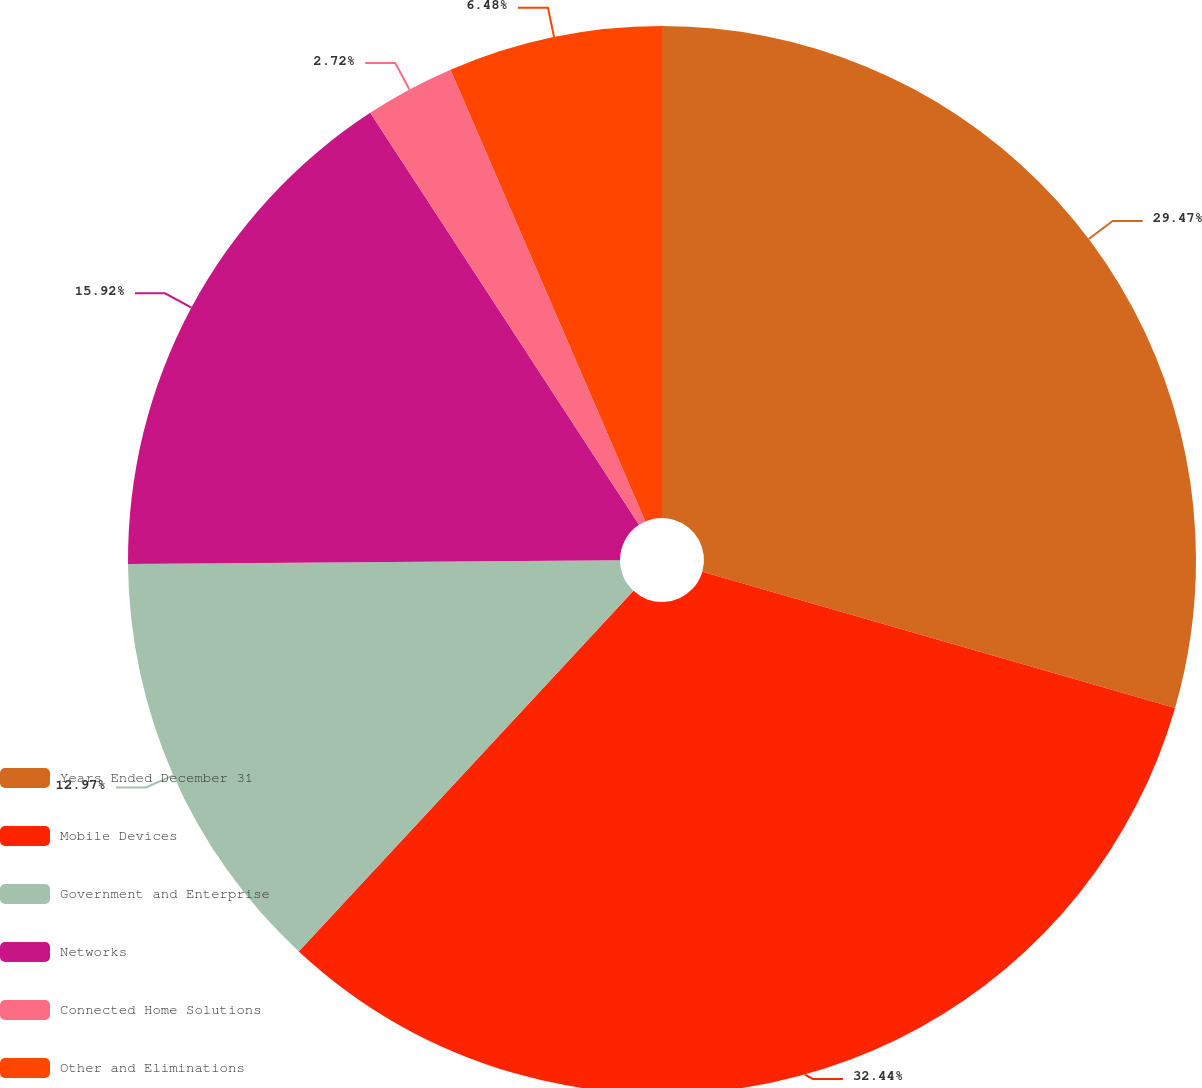Convert chart to OTSL. <chart><loc_0><loc_0><loc_500><loc_500><pie_chart><fcel>Years Ended December 31<fcel>Mobile Devices<fcel>Government and Enterprise<fcel>Networks<fcel>Connected Home Solutions<fcel>Other and Eliminations<nl><fcel>29.47%<fcel>32.43%<fcel>12.97%<fcel>15.92%<fcel>2.72%<fcel>6.48%<nl></chart> 